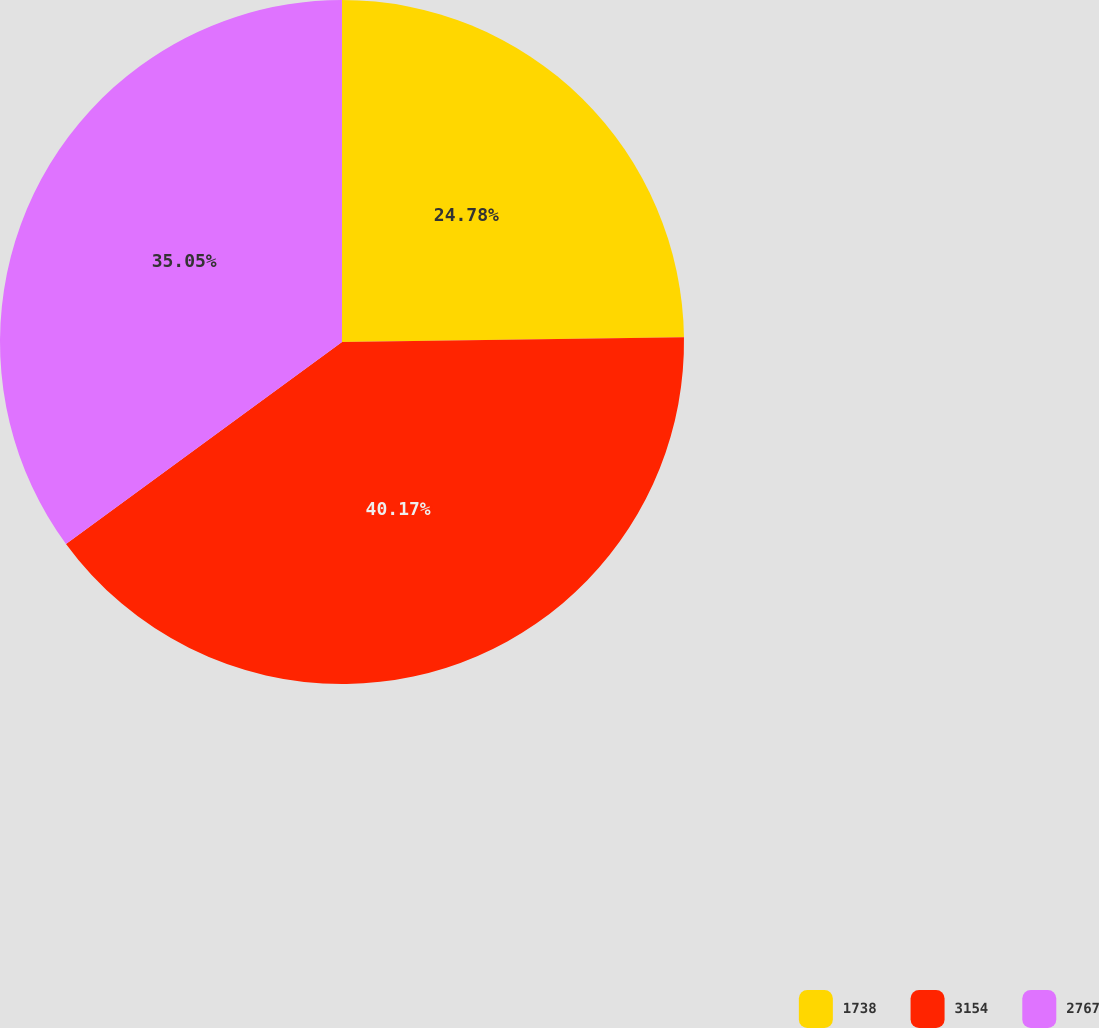Convert chart. <chart><loc_0><loc_0><loc_500><loc_500><pie_chart><fcel>1738<fcel>3154<fcel>2767<nl><fcel>24.78%<fcel>40.16%<fcel>35.05%<nl></chart> 